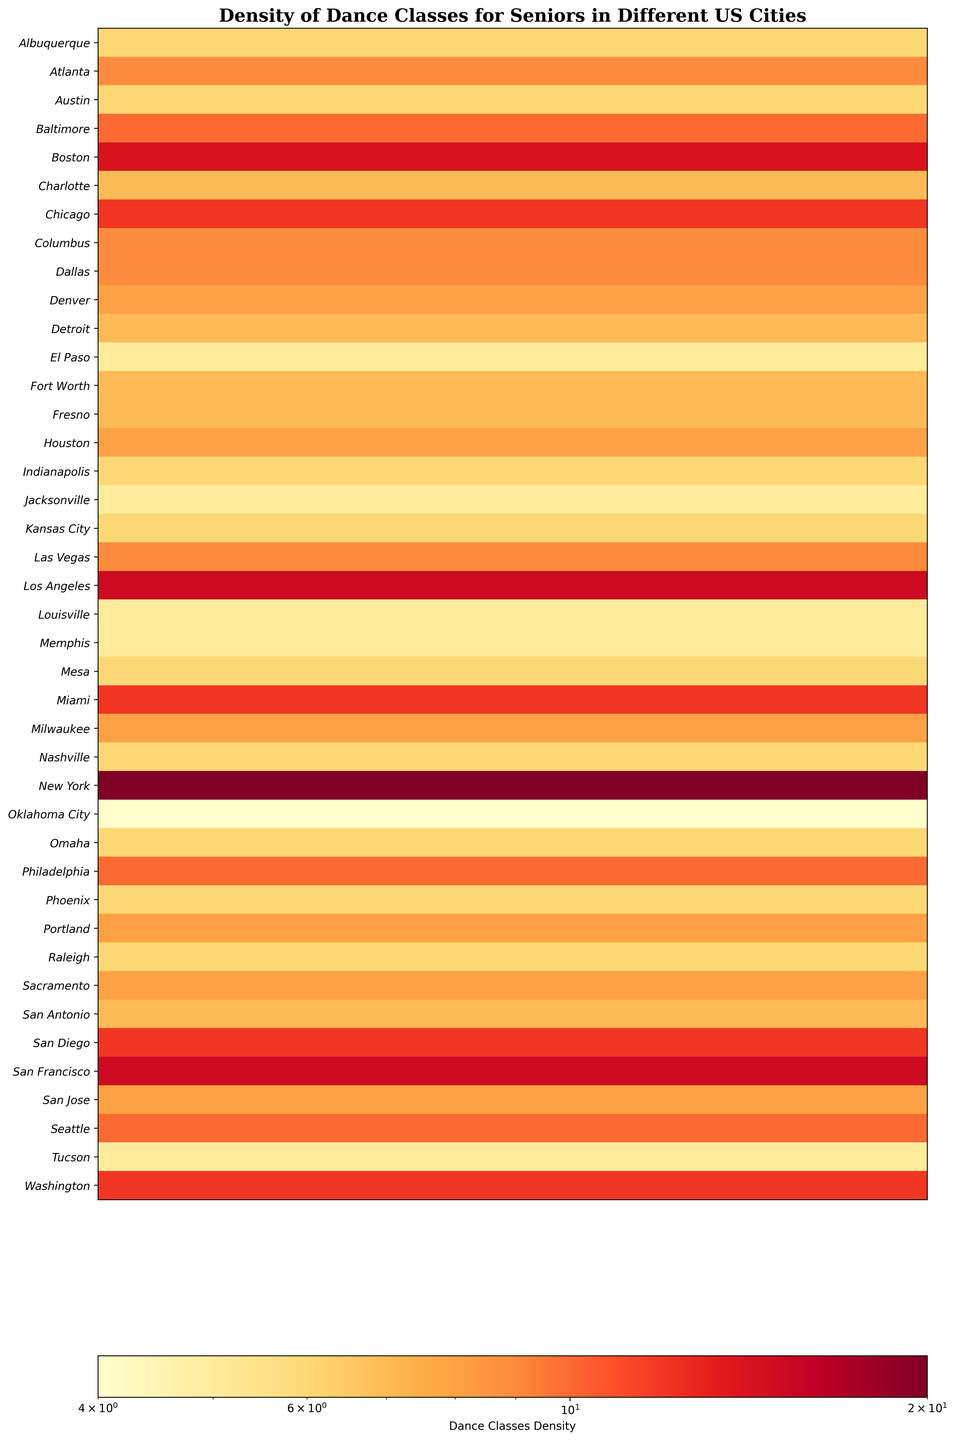Which city has the highest density of dance classes for seniors? Find the city with the darkest red color on the heatmap.
Answer: New York Which city has the lowest density of dance classes for seniors? Identify the city with the lightest color on the heatmap.
Answer: Oklahoma City Is the density of dance classes in Miami closer to that in Boston or Chicago? Compare the color shades for Miami, Boston, and Chicago. Miami and Boston have darker shades, while Chicago has a slightly lighter shade.
Answer: Boston Between San Francisco and Los Angeles, which city has more dance classes per population density? Compare the shades of red. Darker red indicates higher density. San Francisco's color is darker red than Los Angeles.
Answer: San Francisco How does Washington's dance class density compare to that of Houston? Compare the color intensity for both cities. Washington's shade is distinctly darker.
Answer: Washington Which cities have a dance class density similar to San Diego? Look for cities with similar color shades to San Diego, which has a moderate dark orange hue. Cities like Washington and Chicago have similar shades.
Answer: Washington, Chicago What is the average density of dance classes for New York, Los Angeles, and Chicago? Check the density values for these cities: New York (20), Los Angeles (15), and Chicago (12). Calculate the average: (20 + 15 + 12) / 3 = 15.67.
Answer: 15.67 Are there more cities with a dance class density above 10 or below 10? Count cities with density values above and below 10 based on color intensities and side labels. Above 10: New York, Los Angeles, Philadelphia, San Francisco, Chicago, Washington, Boston, Seattle, Miami. Below 10: the rest. More cities are below 10.
Answer: Below 10 Which city has a dance class density closest to Philadelphia's? Identify Philadelphia's density (10) and find a city with a matching or similar shade, such as Seattle and Baltimore.
Answer: Seattle, Baltimore 